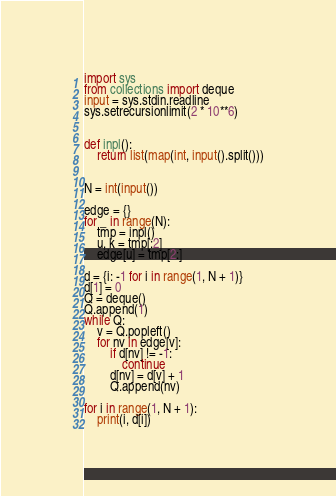Convert code to text. <code><loc_0><loc_0><loc_500><loc_500><_Python_>import sys
from collections import deque
input = sys.stdin.readline
sys.setrecursionlimit(2 * 10**6)


def inpl():
    return list(map(int, input().split()))


N = int(input())

edge = {}
for _ in range(N):
    tmp = inpl()
    u, k = tmp[:2]
    edge[u] = tmp[2:]

d = {i: -1 for i in range(1, N + 1)}
d[1] = 0
Q = deque()
Q.append(1)
while Q:
    v = Q.popleft()
    for nv in edge[v]:
        if d[nv] != -1:
            continue
        d[nv] = d[v] + 1
        Q.append(nv)

for i in range(1, N + 1):
    print(i, d[i])

</code> 